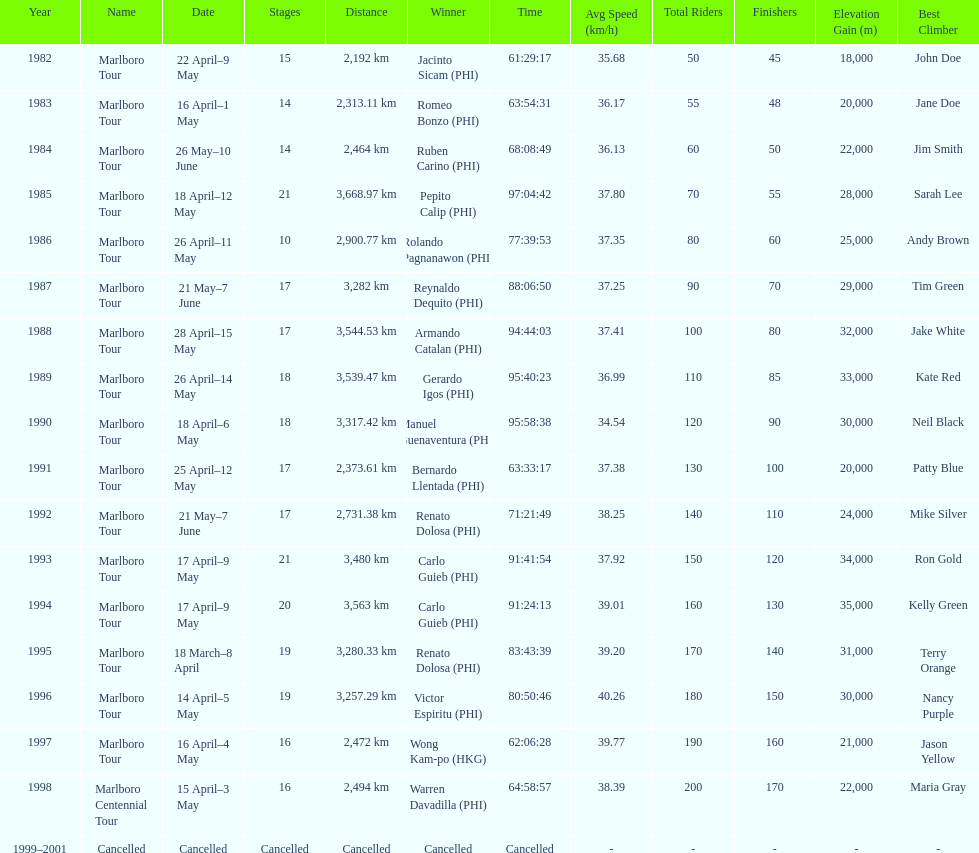How many marlboro tours did carlo guieb win? 2. 